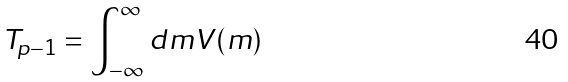<formula> <loc_0><loc_0><loc_500><loc_500>T _ { p - 1 } = \int _ { - \infty } ^ { \infty } d m V ( m )</formula> 